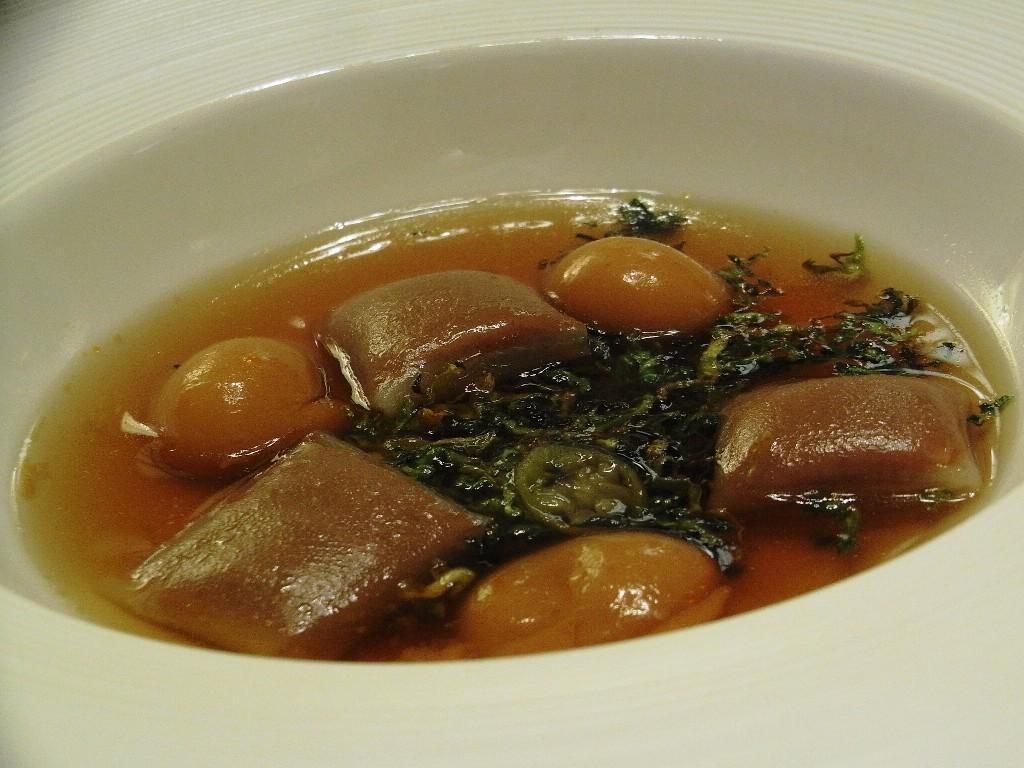Can you describe this image briefly? In this picture we can see a food item in a white color bowl. 